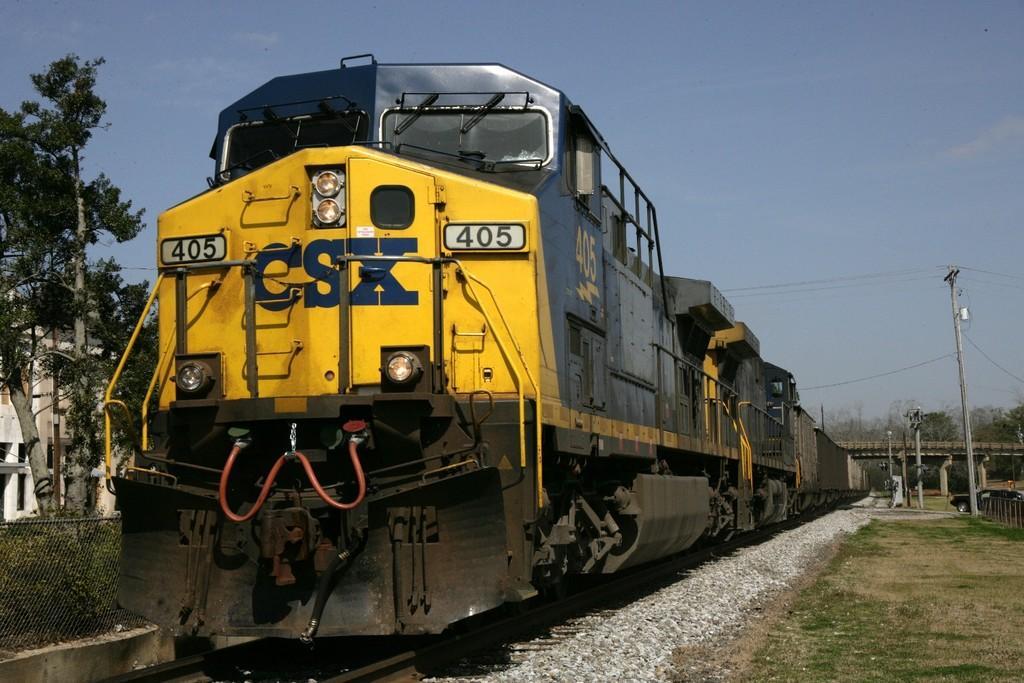Could you give a brief overview of what you see in this image? In this image we can see a train on the track. We can also see some stones, grass, some poles, wires, the bridge, a group of trees, the metal fence and the sky which looks cloudy. 